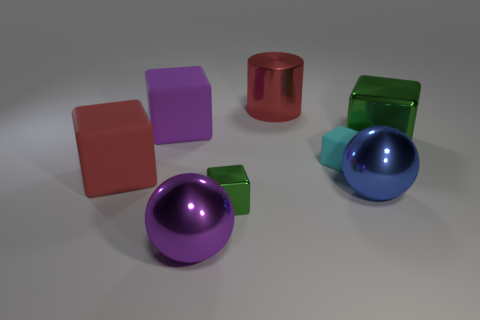What is the texture and lighting like in the scene? The scene presents objects with smooth, reflective surfaces that create an impression of polished metal or plastic. The lighting is soft and diffused, coming from above, casting gentle shadows beneath each object. This illuminates the scene evenly, allowing the colors of the objects to stand out vividly against the light gray background. 